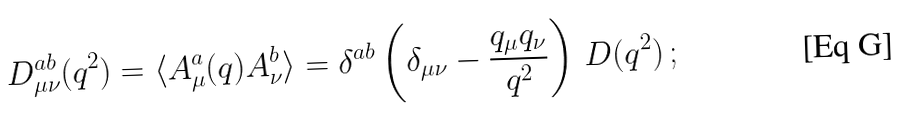Convert formula to latex. <formula><loc_0><loc_0><loc_500><loc_500>D ^ { a b } _ { \mu \nu } ( q ^ { 2 } ) = \langle A ^ { a } _ { \mu } ( q ) A ^ { b } _ { \nu } \rangle = \delta ^ { a b } \left ( \delta _ { \mu \nu } - \frac { q _ { \mu } q _ { \nu } } { q ^ { 2 } } \right ) \, D ( q ^ { 2 } ) \, ;</formula> 